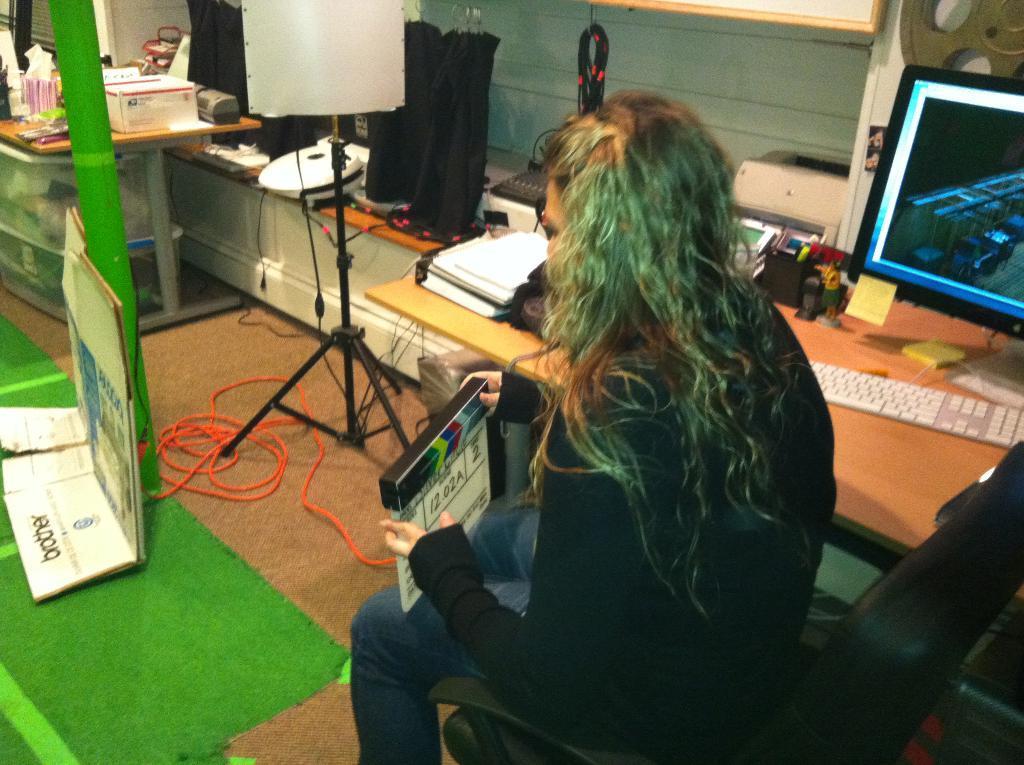Can you describe this image briefly? In this image we can see a lady sitting and holding a clapping slate board. In the background there are tables and we can see a computer, keyboard, books and some objects placed on the tables. We can see a stand and a wire. In the background there is a wall. At the bottom there is a mat and a board. 